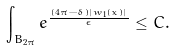Convert formula to latex. <formula><loc_0><loc_0><loc_500><loc_500>\int _ { B _ { 2 \pi } } e ^ { \frac { ( 4 \pi - \delta ) | w _ { 1 } ( x ) | } { \epsilon } } \leq C .</formula> 